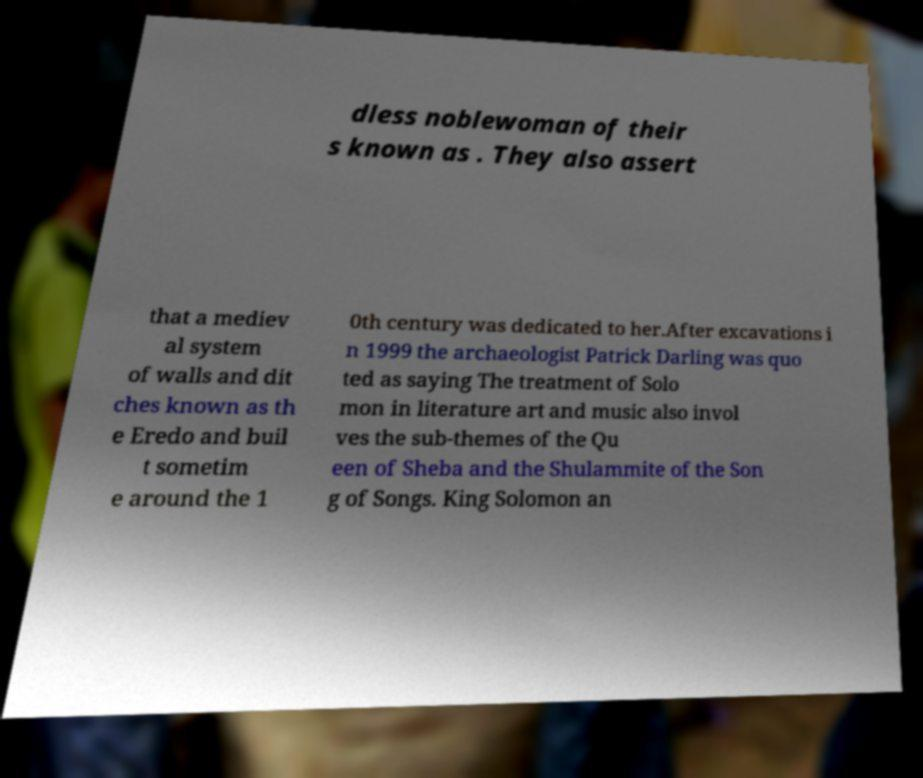Could you assist in decoding the text presented in this image and type it out clearly? dless noblewoman of their s known as . They also assert that a mediev al system of walls and dit ches known as th e Eredo and buil t sometim e around the 1 0th century was dedicated to her.After excavations i n 1999 the archaeologist Patrick Darling was quo ted as saying The treatment of Solo mon in literature art and music also invol ves the sub-themes of the Qu een of Sheba and the Shulammite of the Son g of Songs. King Solomon an 